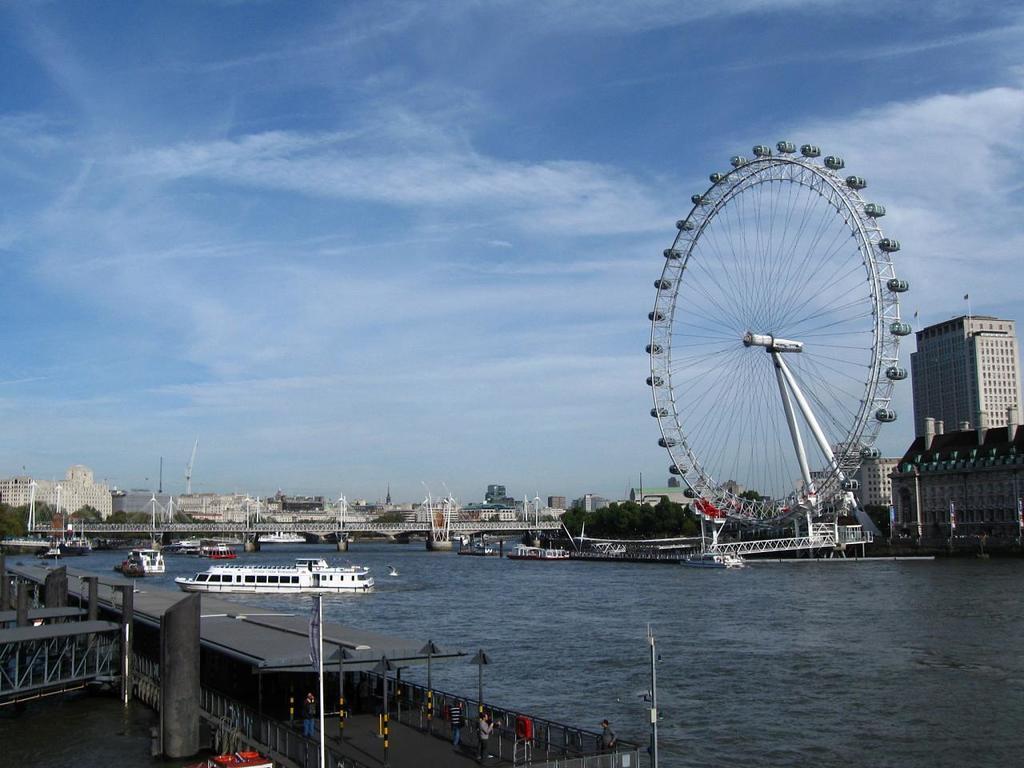In one or two sentences, can you explain what this image depicts? In this picture I can see there is a river and there are few boats sailing on the river, there is a bridge and there are few buildings at left and right and there is a giant wheel at the right side. There are trees and the sky is clear. 